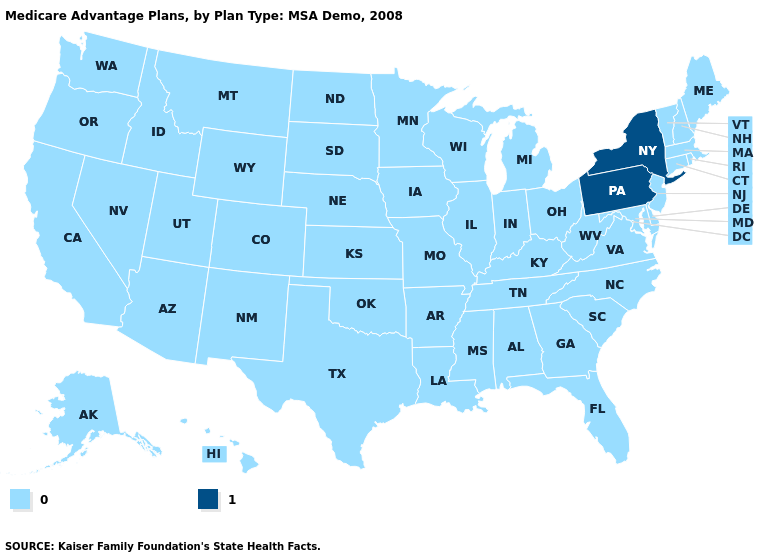Does New York have the highest value in the USA?
Give a very brief answer. Yes. Name the states that have a value in the range 0?
Concise answer only. Alaska, Alabama, Arkansas, Arizona, California, Colorado, Connecticut, Delaware, Florida, Georgia, Hawaii, Iowa, Idaho, Illinois, Indiana, Kansas, Kentucky, Louisiana, Massachusetts, Maryland, Maine, Michigan, Minnesota, Missouri, Mississippi, Montana, North Carolina, North Dakota, Nebraska, New Hampshire, New Jersey, New Mexico, Nevada, Ohio, Oklahoma, Oregon, Rhode Island, South Carolina, South Dakota, Tennessee, Texas, Utah, Virginia, Vermont, Washington, Wisconsin, West Virginia, Wyoming. Does Washington have a higher value than New Hampshire?
Be succinct. No. What is the lowest value in the USA?
Concise answer only. 0. Name the states that have a value in the range 1?
Be succinct. New York, Pennsylvania. What is the value of Maine?
Concise answer only. 0. Name the states that have a value in the range 1?
Answer briefly. New York, Pennsylvania. How many symbols are there in the legend?
Keep it brief. 2. Which states hav the highest value in the MidWest?
Be succinct. Iowa, Illinois, Indiana, Kansas, Michigan, Minnesota, Missouri, North Dakota, Nebraska, Ohio, South Dakota, Wisconsin. What is the value of Maryland?
Concise answer only. 0. Name the states that have a value in the range 0?
Keep it brief. Alaska, Alabama, Arkansas, Arizona, California, Colorado, Connecticut, Delaware, Florida, Georgia, Hawaii, Iowa, Idaho, Illinois, Indiana, Kansas, Kentucky, Louisiana, Massachusetts, Maryland, Maine, Michigan, Minnesota, Missouri, Mississippi, Montana, North Carolina, North Dakota, Nebraska, New Hampshire, New Jersey, New Mexico, Nevada, Ohio, Oklahoma, Oregon, Rhode Island, South Carolina, South Dakota, Tennessee, Texas, Utah, Virginia, Vermont, Washington, Wisconsin, West Virginia, Wyoming. What is the value of Wisconsin?
Be succinct. 0. 